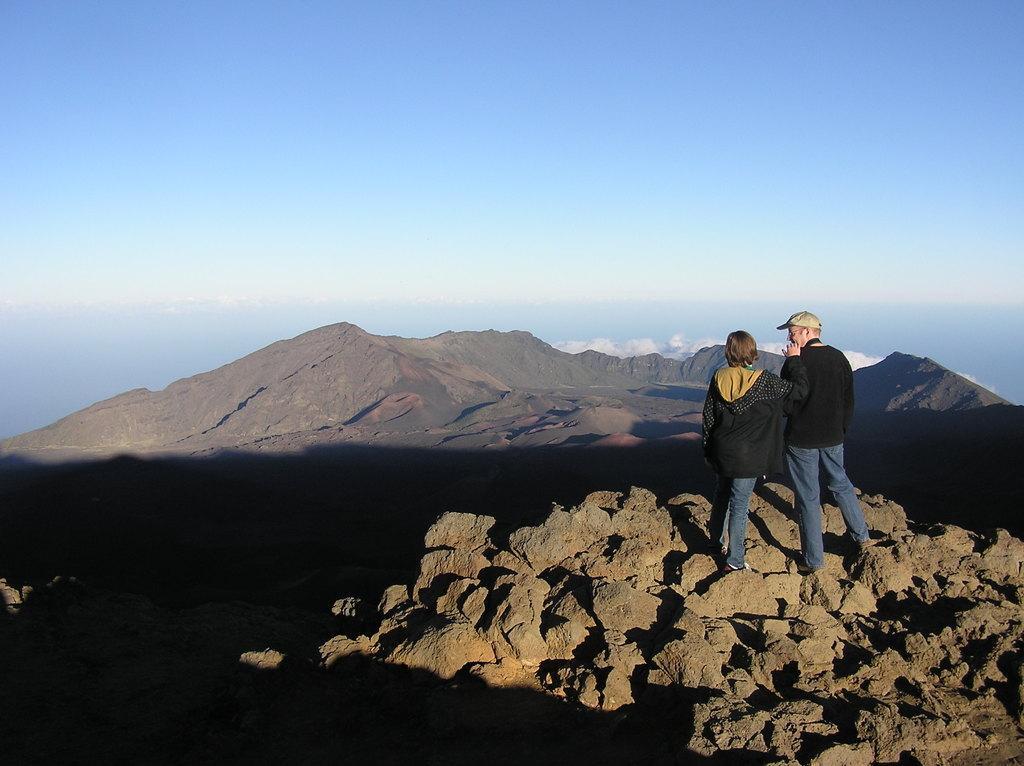Please provide a concise description of this image. In this picture there is a man and a woman on the right side of the image, on the rocks. 